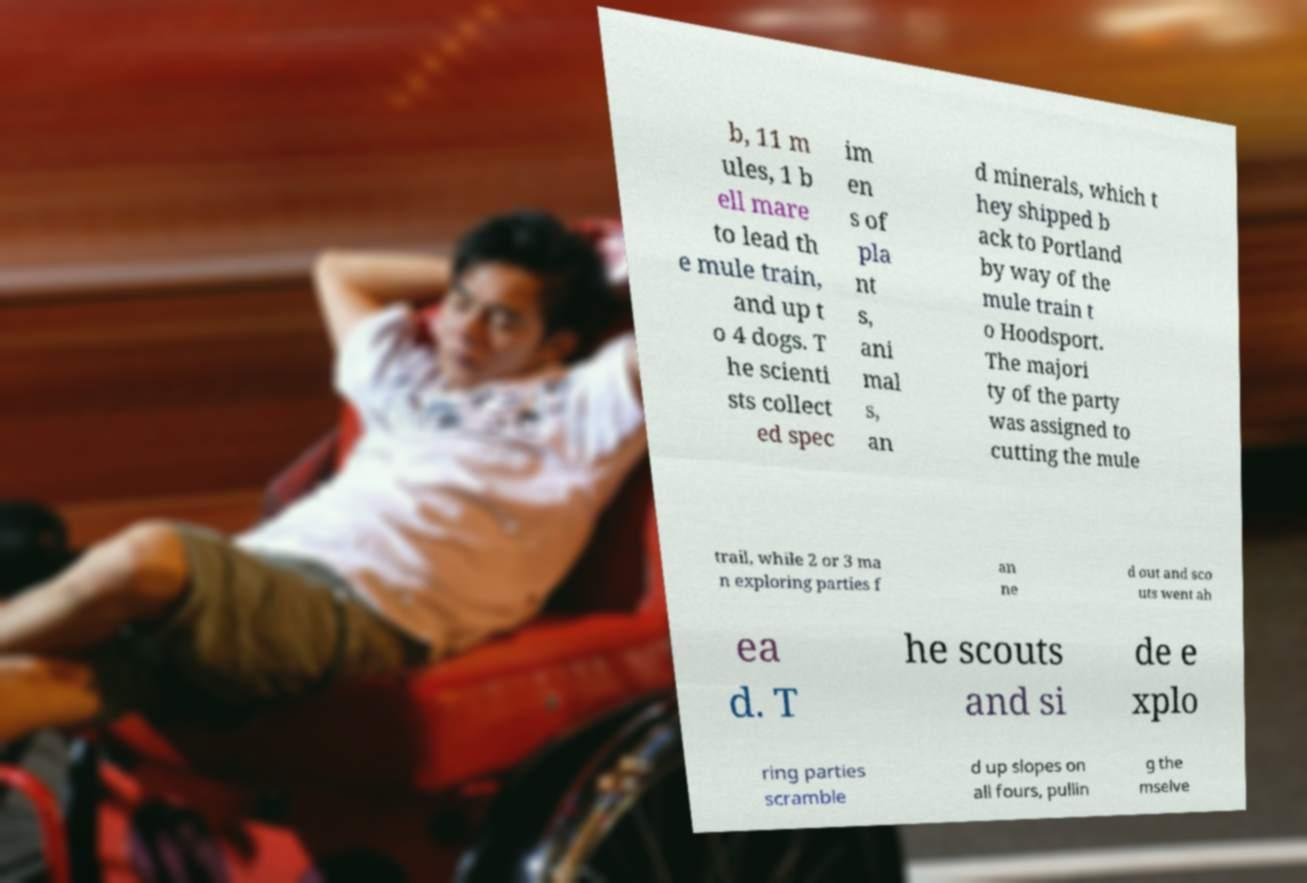Could you assist in decoding the text presented in this image and type it out clearly? b, 11 m ules, 1 b ell mare to lead th e mule train, and up t o 4 dogs. T he scienti sts collect ed spec im en s of pla nt s, ani mal s, an d minerals, which t hey shipped b ack to Portland by way of the mule train t o Hoodsport. The majori ty of the party was assigned to cutting the mule trail, while 2 or 3 ma n exploring parties f an ne d out and sco uts went ah ea d. T he scouts and si de e xplo ring parties scramble d up slopes on all fours, pullin g the mselve 